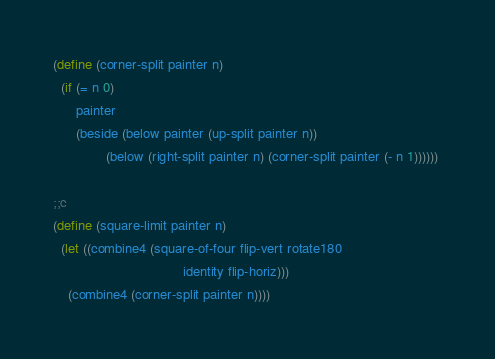<code> <loc_0><loc_0><loc_500><loc_500><_Scheme_>(define (corner-split painter n) 
  (if (= n 0) 
      painter 
      (beside (below painter (up-split painter n)) 
              (below (right-split painter n) (corner-split painter (- n 1)))))) 

;;c
(define (square-limit painter n) 
  (let ((combine4 (square-of-four flip-vert rotate180 
                                  identity flip-horiz))) 
    (combine4 (corner-split painter n)))) 
</code> 